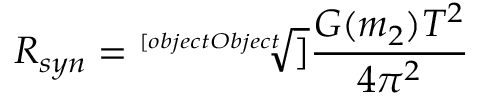Convert formula to latex. <formula><loc_0><loc_0><loc_500><loc_500>R _ { s y n } = { \sqrt { [ } [ o b j e c t O b j e c t ] ] { \frac { G ( m _ { 2 } ) T ^ { 2 } } { 4 \pi ^ { 2 } } } }</formula> 